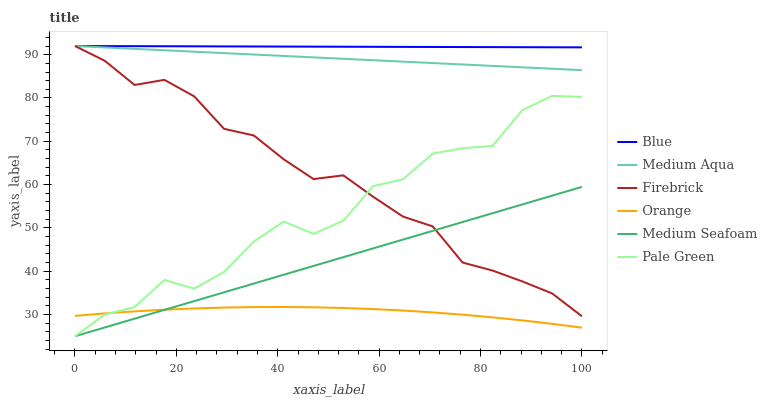Does Orange have the minimum area under the curve?
Answer yes or no. Yes. Does Blue have the maximum area under the curve?
Answer yes or no. Yes. Does Firebrick have the minimum area under the curve?
Answer yes or no. No. Does Firebrick have the maximum area under the curve?
Answer yes or no. No. Is Medium Seafoam the smoothest?
Answer yes or no. Yes. Is Pale Green the roughest?
Answer yes or no. Yes. Is Firebrick the smoothest?
Answer yes or no. No. Is Firebrick the roughest?
Answer yes or no. No. Does Pale Green have the lowest value?
Answer yes or no. Yes. Does Firebrick have the lowest value?
Answer yes or no. No. Does Medium Aqua have the highest value?
Answer yes or no. Yes. Does Pale Green have the highest value?
Answer yes or no. No. Is Orange less than Blue?
Answer yes or no. Yes. Is Blue greater than Orange?
Answer yes or no. Yes. Does Blue intersect Medium Aqua?
Answer yes or no. Yes. Is Blue less than Medium Aqua?
Answer yes or no. No. Is Blue greater than Medium Aqua?
Answer yes or no. No. Does Orange intersect Blue?
Answer yes or no. No. 